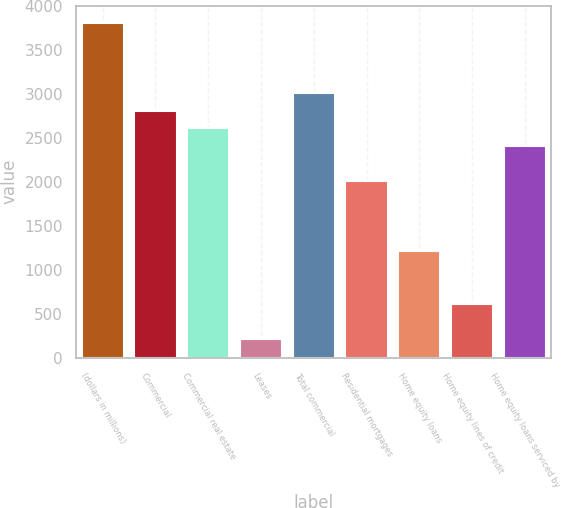Convert chart to OTSL. <chart><loc_0><loc_0><loc_500><loc_500><bar_chart><fcel>(dollars in millions)<fcel>Commercial<fcel>Commercial real estate<fcel>Leases<fcel>Total commercial<fcel>Residential mortgages<fcel>Home equity loans<fcel>Home equity lines of credit<fcel>Home equity loans serviced by<nl><fcel>3812.8<fcel>2811.8<fcel>2611.6<fcel>209.2<fcel>3012<fcel>2011<fcel>1210.2<fcel>609.6<fcel>2411.4<nl></chart> 